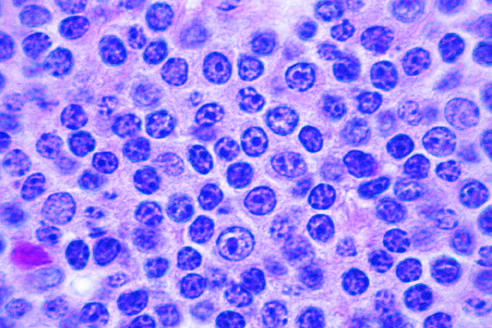do a majority of the tumor cells have the appearance of small, round lymphocytes at high power?
Answer the question using a single word or phrase. Yes 